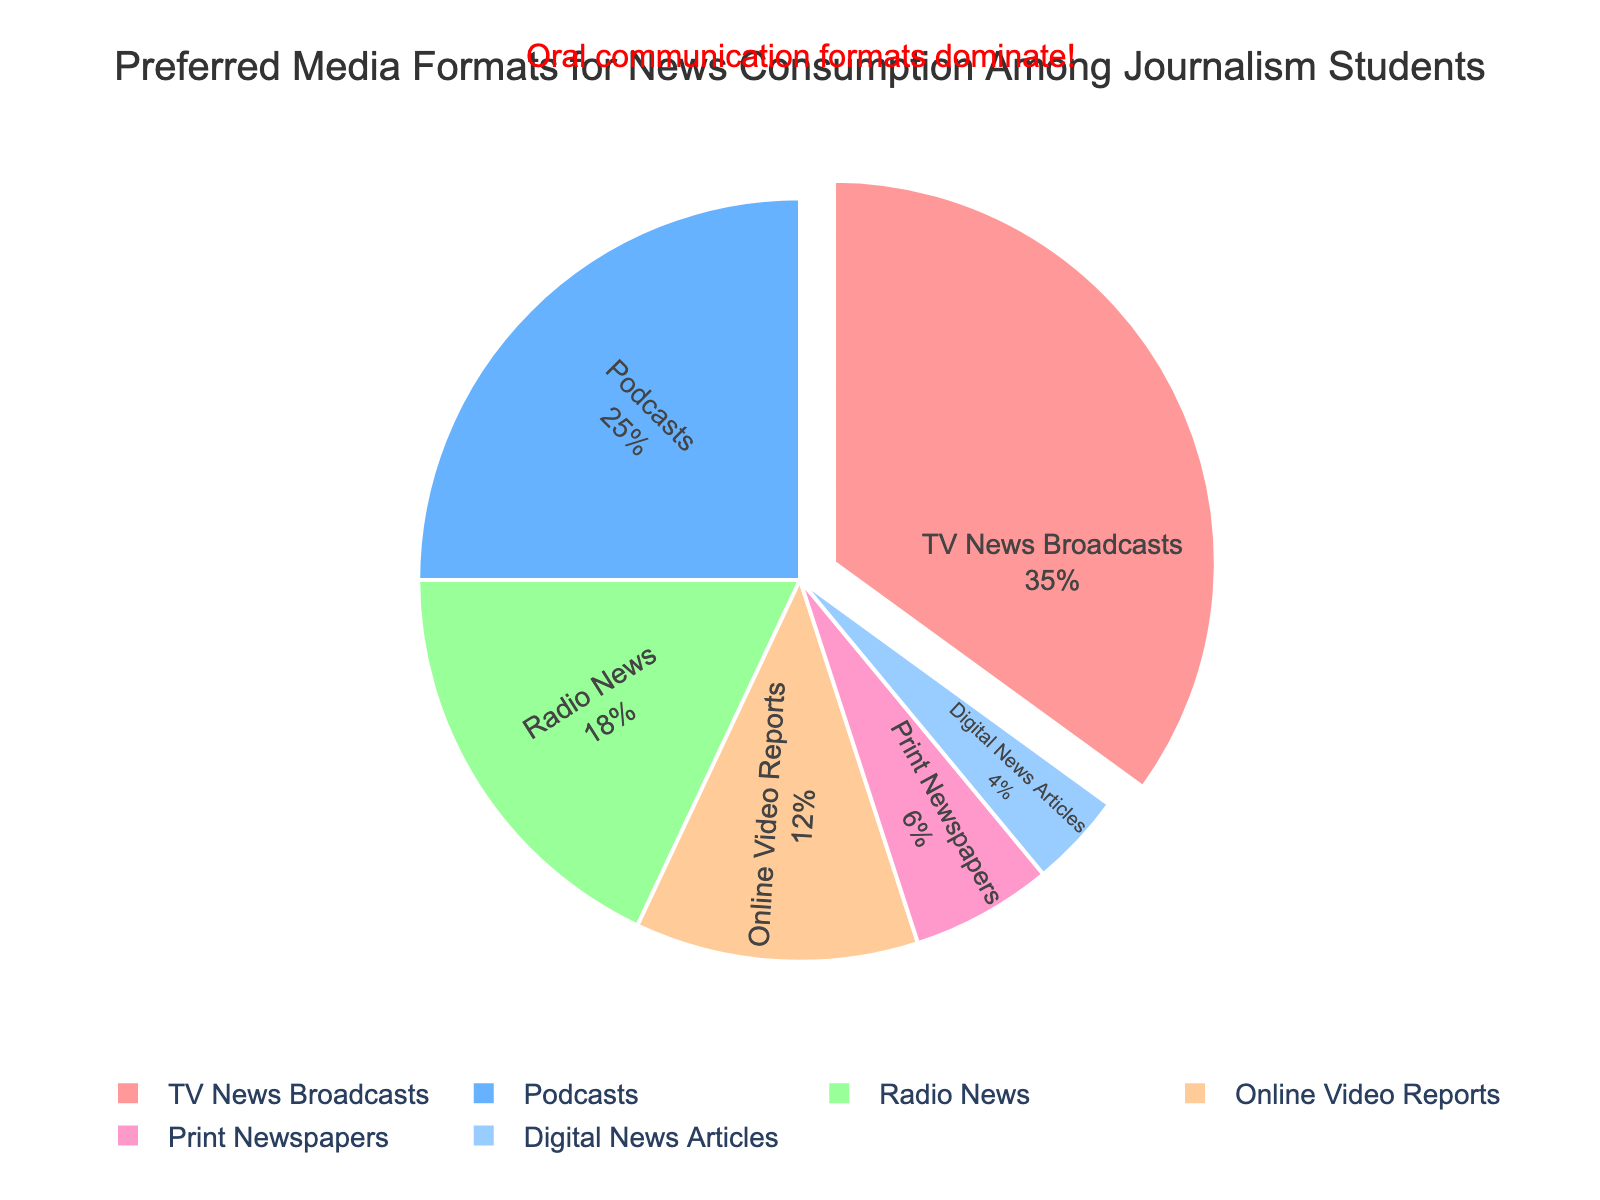What's the largest segment in the pie chart? By observing the pie chart, we see that the segment with the highest percentage is visually the biggest one. This segment represents TV News Broadcasts.
Answer: TV News Broadcasts Which media format has a percentage closest to 10%? By examining the segments, we observe the percentages and see that Online Video Reports have a percentage closest to 10%, with an actual value of 12%.
Answer: Online Video Reports Which format has more preference: Radio News or Digital News Articles? Comparing the sizes of the segments, Radio News has a larger segment of 18%, while Digital News Articles have 4%.
Answer: Radio News What is the combined percentage of Podcasts and Print Newspapers? Summing the percentages of Podcasts (25%) and Print Newspapers (6%) results in 25 + 6 = 31%.
Answer: 31% Is the preference for TV News Broadcasts greater than the combined preference for Podcasts and Online Video Reports? The percentage for TV News Broadcasts is 35%. Adding Podcasts (25%) and Online Video Reports (12%) results in a combined preference of 37%. Therefore, the combined preference is greater than TV News Broadcasts.
Answer: No What percentage difference is there between Radio News and Online Video Reports? The percentage for Radio News is 18% and for Online Video Reports is 12%. The difference is 18 - 12 = 6%.
Answer: 6% Which segment is highlighted with an annotation? By identifying the annotation in the pie chart, we see that it emphasizes "Oral communication formats dominate," and visually, the segments for TV News Broadcasts and Podcasts are among those highlighted as oral formats.
Answer: TV News Broadcasts and Podcasts In terms of visual attributes, which segment is colored blue? By observing the color scheme in the pie chart, we identify that the segment colored blue represents Podcasts.
Answer: Podcasts Which format has the smallest segment in the pie chart? By comparing the size of the segments, the smallest segment represents Digital News Articles, which has the lowest percentage.
Answer: Digital News Articles 